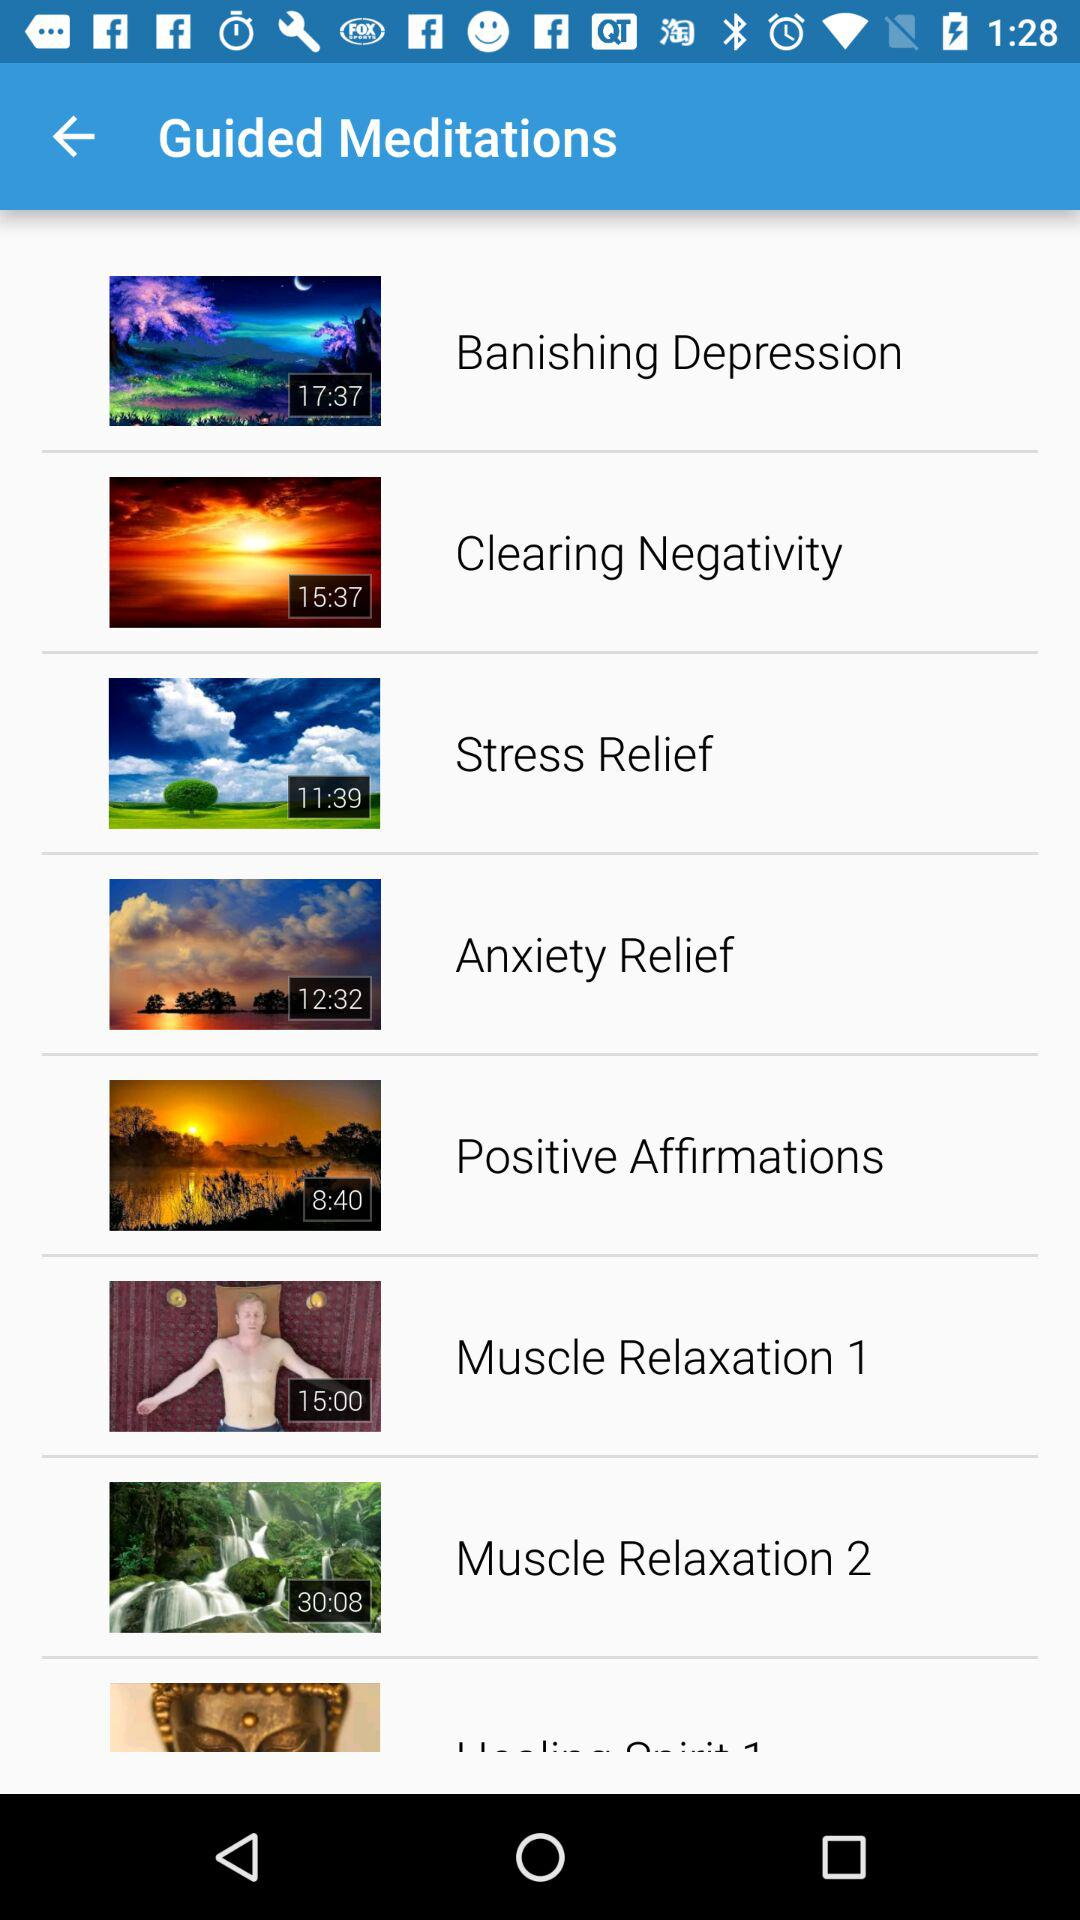What is the duration of "Anxiety Relief" meditation? The duration is 12:32. 